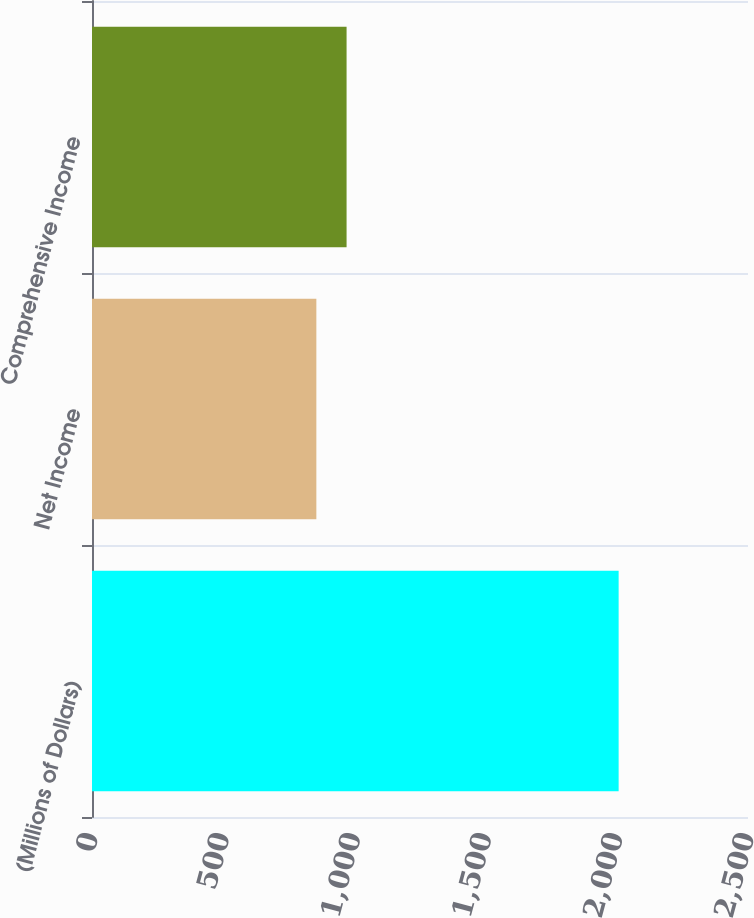Convert chart to OTSL. <chart><loc_0><loc_0><loc_500><loc_500><bar_chart><fcel>(Millions of Dollars)<fcel>Net Income<fcel>Comprehensive Income<nl><fcel>2007<fcel>855<fcel>970.2<nl></chart> 